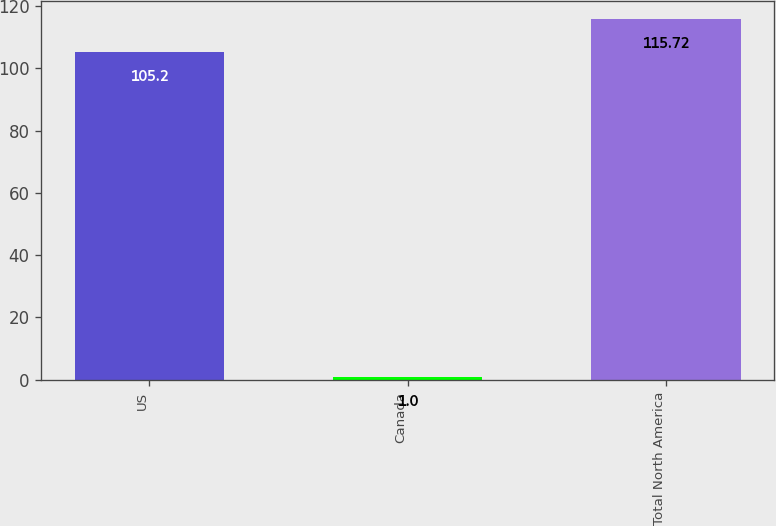Convert chart to OTSL. <chart><loc_0><loc_0><loc_500><loc_500><bar_chart><fcel>US<fcel>Canada<fcel>Total North America<nl><fcel>105.2<fcel>1<fcel>115.72<nl></chart> 